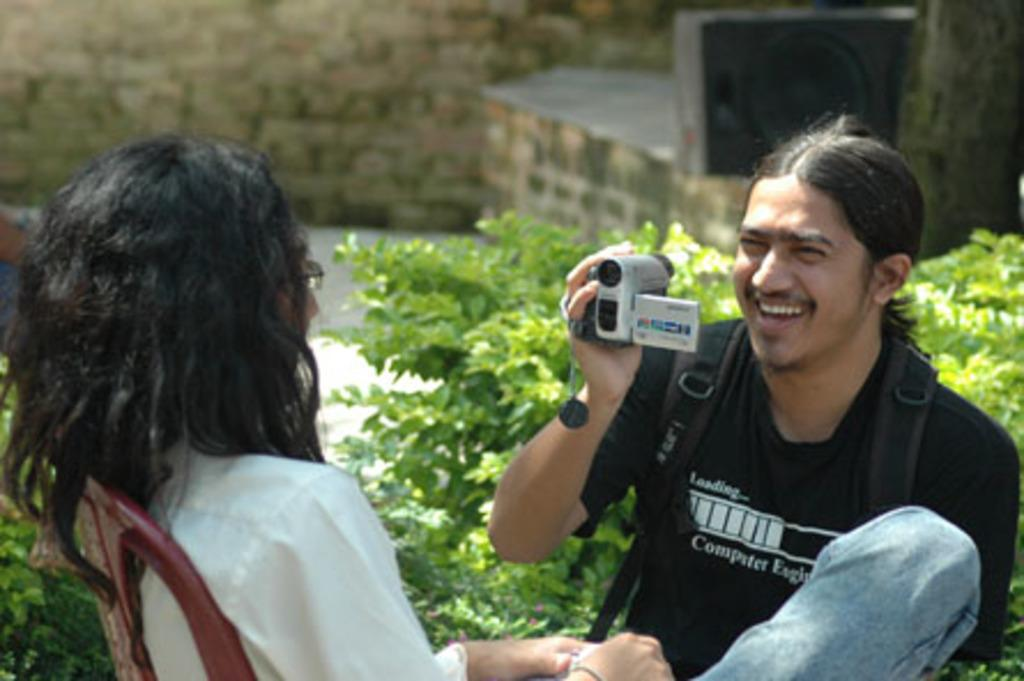What is the man in the image holding? The man is holding a camera in the image. What is the woman in the image doing? The woman is seated on a chair in the image. Can you describe the surroundings in the image? There are plants visible in the image. What type of attack is the man in the image preparing to launch? There is no indication of an attack in the image; the man is simply holding a camera. What thrilling activity is the woman in the image participating in? There is no thrilling activity depicted in the image; the woman is seated on a chair. 